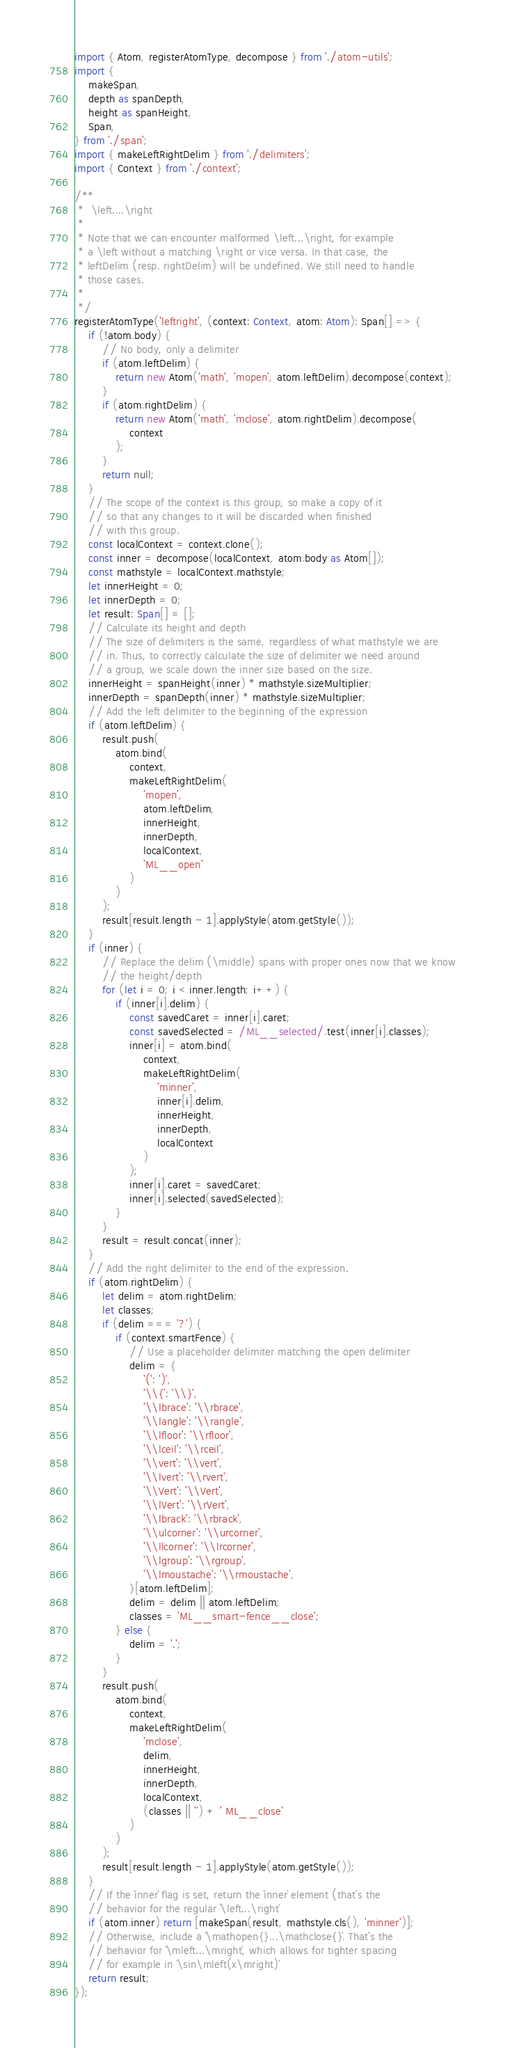<code> <loc_0><loc_0><loc_500><loc_500><_TypeScript_>import { Atom, registerAtomType, decompose } from './atom-utils';
import {
    makeSpan,
    depth as spanDepth,
    height as spanHeight,
    Span,
} from './span';
import { makeLeftRightDelim } from './delimiters';
import { Context } from './context';

/**
 *  \left....\right
 *
 * Note that we can encounter malformed \left...\right, for example
 * a \left without a matching \right or vice versa. In that case, the
 * leftDelim (resp. rightDelim) will be undefined. We still need to handle
 * those cases.
 *
 */
registerAtomType('leftright', (context: Context, atom: Atom): Span[] => {
    if (!atom.body) {
        // No body, only a delimiter
        if (atom.leftDelim) {
            return new Atom('math', 'mopen', atom.leftDelim).decompose(context);
        }
        if (atom.rightDelim) {
            return new Atom('math', 'mclose', atom.rightDelim).decompose(
                context
            );
        }
        return null;
    }
    // The scope of the context is this group, so make a copy of it
    // so that any changes to it will be discarded when finished
    // with this group.
    const localContext = context.clone();
    const inner = decompose(localContext, atom.body as Atom[]);
    const mathstyle = localContext.mathstyle;
    let innerHeight = 0;
    let innerDepth = 0;
    let result: Span[] = [];
    // Calculate its height and depth
    // The size of delimiters is the same, regardless of what mathstyle we are
    // in. Thus, to correctly calculate the size of delimiter we need around
    // a group, we scale down the inner size based on the size.
    innerHeight = spanHeight(inner) * mathstyle.sizeMultiplier;
    innerDepth = spanDepth(inner) * mathstyle.sizeMultiplier;
    // Add the left delimiter to the beginning of the expression
    if (atom.leftDelim) {
        result.push(
            atom.bind(
                context,
                makeLeftRightDelim(
                    'mopen',
                    atom.leftDelim,
                    innerHeight,
                    innerDepth,
                    localContext,
                    'ML__open'
                )
            )
        );
        result[result.length - 1].applyStyle(atom.getStyle());
    }
    if (inner) {
        // Replace the delim (\middle) spans with proper ones now that we know
        // the height/depth
        for (let i = 0; i < inner.length; i++) {
            if (inner[i].delim) {
                const savedCaret = inner[i].caret;
                const savedSelected = /ML__selected/.test(inner[i].classes);
                inner[i] = atom.bind(
                    context,
                    makeLeftRightDelim(
                        'minner',
                        inner[i].delim,
                        innerHeight,
                        innerDepth,
                        localContext
                    )
                );
                inner[i].caret = savedCaret;
                inner[i].selected(savedSelected);
            }
        }
        result = result.concat(inner);
    }
    // Add the right delimiter to the end of the expression.
    if (atom.rightDelim) {
        let delim = atom.rightDelim;
        let classes;
        if (delim === '?') {
            if (context.smartFence) {
                // Use a placeholder delimiter matching the open delimiter
                delim = {
                    '(': ')',
                    '\\{': '\\}',
                    '\\lbrace': '\\rbrace',
                    '\\langle': '\\rangle',
                    '\\lfloor': '\\rfloor',
                    '\\lceil': '\\rceil',
                    '\\vert': '\\vert',
                    '\\lvert': '\\rvert',
                    '\\Vert': '\\Vert',
                    '\\lVert': '\\rVert',
                    '\\lbrack': '\\rbrack',
                    '\\ulcorner': '\\urcorner',
                    '\\llcorner': '\\lrcorner',
                    '\\lgroup': '\\rgroup',
                    '\\lmoustache': '\\rmoustache',
                }[atom.leftDelim];
                delim = delim || atom.leftDelim;
                classes = 'ML__smart-fence__close';
            } else {
                delim = '.';
            }
        }
        result.push(
            atom.bind(
                context,
                makeLeftRightDelim(
                    'mclose',
                    delim,
                    innerHeight,
                    innerDepth,
                    localContext,
                    (classes || '') + ' ML__close'
                )
            )
        );
        result[result.length - 1].applyStyle(atom.getStyle());
    }
    // If the `inner` flag is set, return the `inner` element (that's the
    // behavior for the regular `\left...\right`
    if (atom.inner) return [makeSpan(result, mathstyle.cls(), 'minner')];
    // Otherwise, include a `\mathopen{}...\mathclose{}`. That's the
    // behavior for `\mleft...\mright`, which allows for tighter spacing
    // for example in `\sin\mleft(x\mright)`
    return result;
});
</code> 